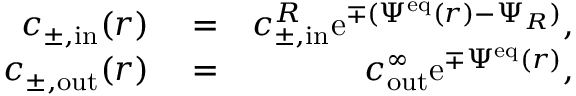<formula> <loc_0><loc_0><loc_500><loc_500>\begin{array} { r l r } { c _ { \pm , i n } ( r ) } & = } & { c _ { \pm , i n } ^ { R } e ^ { \mp ( \Psi ^ { e q } ( r ) - \Psi _ { R } ) } , } \\ { c _ { \pm , o u t } ( r ) } & = } & { c _ { o u t } ^ { \infty } e ^ { \mp \Psi ^ { e q } ( r ) } , } \end{array}</formula> 